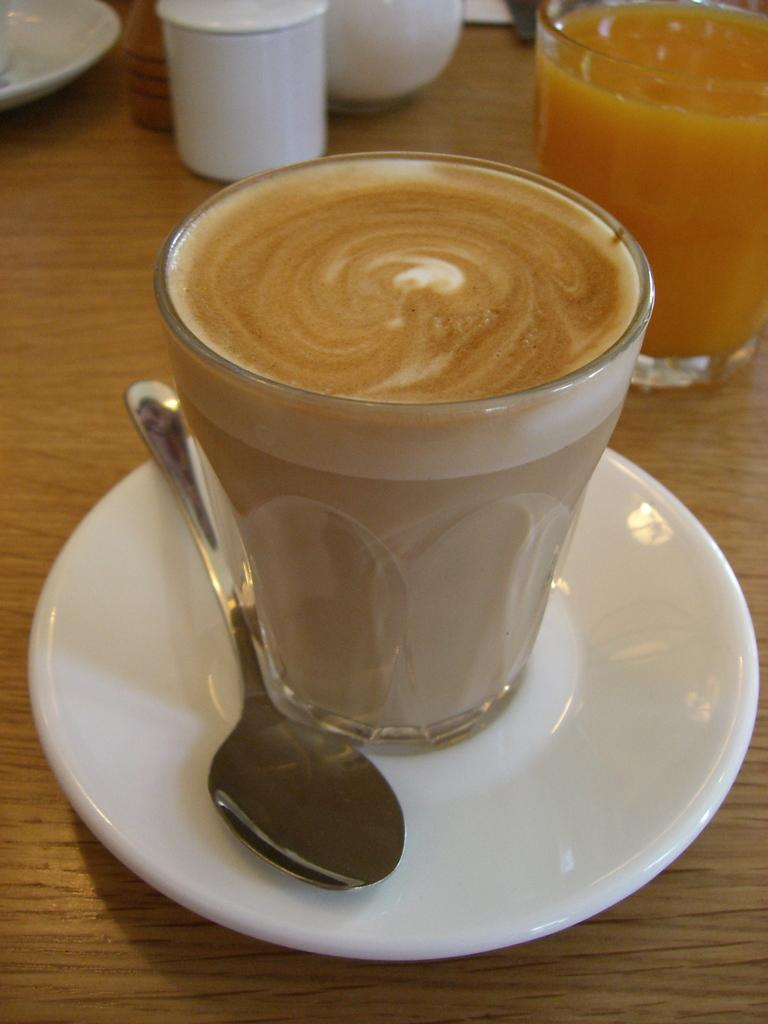What type of object can be seen in the image that is typically used for drinking? There is a glass in the image that is typically used for drinking. What utensil is visible in the image? There is a spoon in the image. What is the flat, round object that the glass and spoon are placed on? There is a saucer in the image, and it is on a table. What can be seen in the background of the image? There are ceramic containers in the background of the image. What type of humor can be seen in the image? There is no humor present in the image; it is a still life of objects on a table. Is there a jail visible in the image? There is no jail present in the image. 